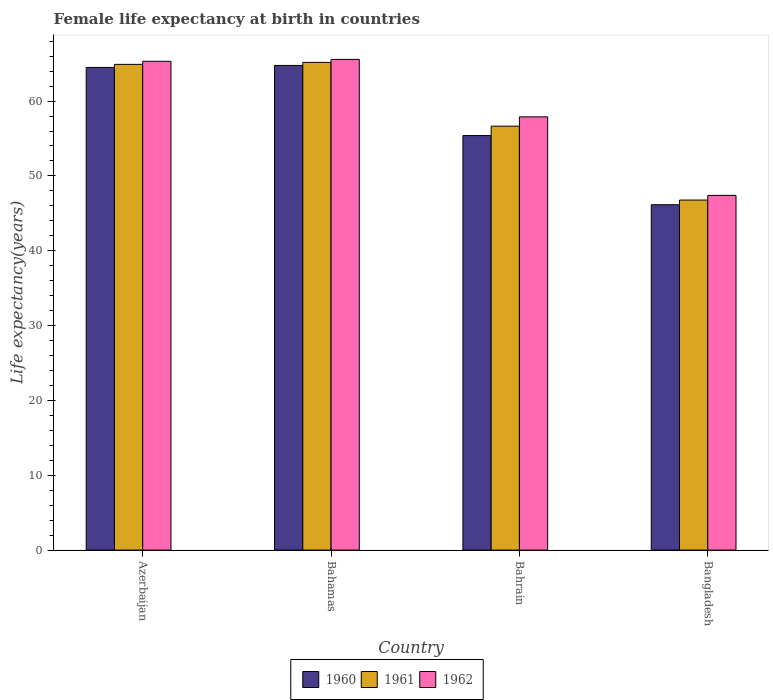How many different coloured bars are there?
Your response must be concise. 3. How many groups of bars are there?
Your answer should be very brief. 4. Are the number of bars per tick equal to the number of legend labels?
Offer a terse response. Yes. How many bars are there on the 3rd tick from the left?
Keep it short and to the point. 3. What is the label of the 1st group of bars from the left?
Offer a terse response. Azerbaijan. What is the female life expectancy at birth in 1960 in Bahrain?
Give a very brief answer. 55.39. Across all countries, what is the maximum female life expectancy at birth in 1962?
Ensure brevity in your answer.  65.57. Across all countries, what is the minimum female life expectancy at birth in 1960?
Give a very brief answer. 46.15. In which country was the female life expectancy at birth in 1961 maximum?
Offer a very short reply. Bahamas. In which country was the female life expectancy at birth in 1962 minimum?
Your response must be concise. Bangladesh. What is the total female life expectancy at birth in 1962 in the graph?
Provide a short and direct response. 236.18. What is the difference between the female life expectancy at birth in 1960 in Azerbaijan and that in Bahrain?
Offer a very short reply. 9.11. What is the difference between the female life expectancy at birth in 1960 in Bahrain and the female life expectancy at birth in 1961 in Azerbaijan?
Your response must be concise. -9.51. What is the average female life expectancy at birth in 1961 per country?
Provide a succinct answer. 58.38. What is the difference between the female life expectancy at birth of/in 1961 and female life expectancy at birth of/in 1962 in Bahrain?
Provide a succinct answer. -1.24. What is the ratio of the female life expectancy at birth in 1962 in Azerbaijan to that in Bahrain?
Keep it short and to the point. 1.13. Is the female life expectancy at birth in 1962 in Azerbaijan less than that in Bahamas?
Ensure brevity in your answer.  Yes. Is the difference between the female life expectancy at birth in 1961 in Azerbaijan and Bangladesh greater than the difference between the female life expectancy at birth in 1962 in Azerbaijan and Bangladesh?
Provide a succinct answer. Yes. What is the difference between the highest and the second highest female life expectancy at birth in 1961?
Ensure brevity in your answer.  -0.27. What is the difference between the highest and the lowest female life expectancy at birth in 1961?
Give a very brief answer. 18.4. In how many countries, is the female life expectancy at birth in 1962 greater than the average female life expectancy at birth in 1962 taken over all countries?
Make the answer very short. 2. What does the 2nd bar from the right in Bangladesh represents?
Your response must be concise. 1961. Are the values on the major ticks of Y-axis written in scientific E-notation?
Offer a terse response. No. Does the graph contain grids?
Make the answer very short. No. Where does the legend appear in the graph?
Your answer should be very brief. Bottom center. How are the legend labels stacked?
Provide a short and direct response. Horizontal. What is the title of the graph?
Keep it short and to the point. Female life expectancy at birth in countries. What is the label or title of the X-axis?
Make the answer very short. Country. What is the label or title of the Y-axis?
Ensure brevity in your answer.  Life expectancy(years). What is the Life expectancy(years) of 1960 in Azerbaijan?
Ensure brevity in your answer.  64.5. What is the Life expectancy(years) in 1961 in Azerbaijan?
Provide a short and direct response. 64.91. What is the Life expectancy(years) of 1962 in Azerbaijan?
Ensure brevity in your answer.  65.32. What is the Life expectancy(years) in 1960 in Bahamas?
Ensure brevity in your answer.  64.76. What is the Life expectancy(years) in 1961 in Bahamas?
Provide a short and direct response. 65.17. What is the Life expectancy(years) of 1962 in Bahamas?
Provide a succinct answer. 65.57. What is the Life expectancy(years) of 1960 in Bahrain?
Your answer should be very brief. 55.39. What is the Life expectancy(years) of 1961 in Bahrain?
Your answer should be compact. 56.65. What is the Life expectancy(years) in 1962 in Bahrain?
Offer a very short reply. 57.89. What is the Life expectancy(years) of 1960 in Bangladesh?
Offer a very short reply. 46.15. What is the Life expectancy(years) in 1961 in Bangladesh?
Your answer should be very brief. 46.78. What is the Life expectancy(years) in 1962 in Bangladesh?
Offer a terse response. 47.4. Across all countries, what is the maximum Life expectancy(years) of 1960?
Your response must be concise. 64.76. Across all countries, what is the maximum Life expectancy(years) of 1961?
Your response must be concise. 65.17. Across all countries, what is the maximum Life expectancy(years) in 1962?
Make the answer very short. 65.57. Across all countries, what is the minimum Life expectancy(years) of 1960?
Your response must be concise. 46.15. Across all countries, what is the minimum Life expectancy(years) of 1961?
Make the answer very short. 46.78. Across all countries, what is the minimum Life expectancy(years) of 1962?
Offer a terse response. 47.4. What is the total Life expectancy(years) of 1960 in the graph?
Provide a short and direct response. 230.81. What is the total Life expectancy(years) of 1961 in the graph?
Provide a short and direct response. 233.5. What is the total Life expectancy(years) of 1962 in the graph?
Give a very brief answer. 236.18. What is the difference between the Life expectancy(years) in 1960 in Azerbaijan and that in Bahamas?
Make the answer very short. -0.26. What is the difference between the Life expectancy(years) in 1961 in Azerbaijan and that in Bahamas?
Make the answer very short. -0.27. What is the difference between the Life expectancy(years) in 1962 in Azerbaijan and that in Bahamas?
Offer a very short reply. -0.25. What is the difference between the Life expectancy(years) of 1960 in Azerbaijan and that in Bahrain?
Your answer should be very brief. 9.11. What is the difference between the Life expectancy(years) in 1961 in Azerbaijan and that in Bahrain?
Offer a terse response. 8.26. What is the difference between the Life expectancy(years) in 1962 in Azerbaijan and that in Bahrain?
Your response must be concise. 7.42. What is the difference between the Life expectancy(years) of 1960 in Azerbaijan and that in Bangladesh?
Your answer should be very brief. 18.35. What is the difference between the Life expectancy(years) in 1961 in Azerbaijan and that in Bangladesh?
Provide a succinct answer. 18.13. What is the difference between the Life expectancy(years) of 1962 in Azerbaijan and that in Bangladesh?
Give a very brief answer. 17.92. What is the difference between the Life expectancy(years) of 1960 in Bahamas and that in Bahrain?
Your answer should be very brief. 9.37. What is the difference between the Life expectancy(years) in 1961 in Bahamas and that in Bahrain?
Ensure brevity in your answer.  8.52. What is the difference between the Life expectancy(years) of 1962 in Bahamas and that in Bahrain?
Ensure brevity in your answer.  7.68. What is the difference between the Life expectancy(years) in 1960 in Bahamas and that in Bangladesh?
Provide a succinct answer. 18.61. What is the difference between the Life expectancy(years) in 1961 in Bahamas and that in Bangladesh?
Provide a short and direct response. 18.4. What is the difference between the Life expectancy(years) of 1962 in Bahamas and that in Bangladesh?
Offer a terse response. 18.17. What is the difference between the Life expectancy(years) in 1960 in Bahrain and that in Bangladesh?
Ensure brevity in your answer.  9.24. What is the difference between the Life expectancy(years) in 1961 in Bahrain and that in Bangladesh?
Offer a very short reply. 9.87. What is the difference between the Life expectancy(years) in 1962 in Bahrain and that in Bangladesh?
Keep it short and to the point. 10.49. What is the difference between the Life expectancy(years) in 1960 in Azerbaijan and the Life expectancy(years) in 1961 in Bahamas?
Give a very brief answer. -0.67. What is the difference between the Life expectancy(years) in 1960 in Azerbaijan and the Life expectancy(years) in 1962 in Bahamas?
Your answer should be very brief. -1.07. What is the difference between the Life expectancy(years) of 1961 in Azerbaijan and the Life expectancy(years) of 1962 in Bahamas?
Provide a succinct answer. -0.66. What is the difference between the Life expectancy(years) of 1960 in Azerbaijan and the Life expectancy(years) of 1961 in Bahrain?
Ensure brevity in your answer.  7.85. What is the difference between the Life expectancy(years) in 1960 in Azerbaijan and the Life expectancy(years) in 1962 in Bahrain?
Provide a short and direct response. 6.61. What is the difference between the Life expectancy(years) of 1961 in Azerbaijan and the Life expectancy(years) of 1962 in Bahrain?
Make the answer very short. 7.01. What is the difference between the Life expectancy(years) of 1960 in Azerbaijan and the Life expectancy(years) of 1961 in Bangladesh?
Your answer should be compact. 17.73. What is the difference between the Life expectancy(years) in 1960 in Azerbaijan and the Life expectancy(years) in 1962 in Bangladesh?
Offer a very short reply. 17.1. What is the difference between the Life expectancy(years) in 1961 in Azerbaijan and the Life expectancy(years) in 1962 in Bangladesh?
Ensure brevity in your answer.  17.51. What is the difference between the Life expectancy(years) of 1960 in Bahamas and the Life expectancy(years) of 1961 in Bahrain?
Your answer should be compact. 8.11. What is the difference between the Life expectancy(years) in 1960 in Bahamas and the Life expectancy(years) in 1962 in Bahrain?
Your response must be concise. 6.87. What is the difference between the Life expectancy(years) in 1961 in Bahamas and the Life expectancy(years) in 1962 in Bahrain?
Your answer should be very brief. 7.28. What is the difference between the Life expectancy(years) in 1960 in Bahamas and the Life expectancy(years) in 1961 in Bangladesh?
Make the answer very short. 17.99. What is the difference between the Life expectancy(years) in 1960 in Bahamas and the Life expectancy(years) in 1962 in Bangladesh?
Your response must be concise. 17.36. What is the difference between the Life expectancy(years) of 1961 in Bahamas and the Life expectancy(years) of 1962 in Bangladesh?
Provide a short and direct response. 17.77. What is the difference between the Life expectancy(years) in 1960 in Bahrain and the Life expectancy(years) in 1961 in Bangladesh?
Provide a short and direct response. 8.62. What is the difference between the Life expectancy(years) in 1960 in Bahrain and the Life expectancy(years) in 1962 in Bangladesh?
Provide a short and direct response. 7.99. What is the difference between the Life expectancy(years) of 1961 in Bahrain and the Life expectancy(years) of 1962 in Bangladesh?
Offer a very short reply. 9.25. What is the average Life expectancy(years) of 1960 per country?
Offer a terse response. 57.7. What is the average Life expectancy(years) of 1961 per country?
Make the answer very short. 58.38. What is the average Life expectancy(years) of 1962 per country?
Your answer should be very brief. 59.05. What is the difference between the Life expectancy(years) of 1960 and Life expectancy(years) of 1961 in Azerbaijan?
Offer a very short reply. -0.41. What is the difference between the Life expectancy(years) in 1960 and Life expectancy(years) in 1962 in Azerbaijan?
Make the answer very short. -0.81. What is the difference between the Life expectancy(years) in 1961 and Life expectancy(years) in 1962 in Azerbaijan?
Provide a short and direct response. -0.41. What is the difference between the Life expectancy(years) of 1960 and Life expectancy(years) of 1961 in Bahamas?
Offer a very short reply. -0.41. What is the difference between the Life expectancy(years) of 1960 and Life expectancy(years) of 1962 in Bahamas?
Make the answer very short. -0.81. What is the difference between the Life expectancy(years) of 1961 and Life expectancy(years) of 1962 in Bahamas?
Keep it short and to the point. -0.4. What is the difference between the Life expectancy(years) in 1960 and Life expectancy(years) in 1961 in Bahrain?
Ensure brevity in your answer.  -1.26. What is the difference between the Life expectancy(years) of 1960 and Life expectancy(years) of 1962 in Bahrain?
Provide a succinct answer. -2.5. What is the difference between the Life expectancy(years) in 1961 and Life expectancy(years) in 1962 in Bahrain?
Make the answer very short. -1.24. What is the difference between the Life expectancy(years) in 1960 and Life expectancy(years) in 1961 in Bangladesh?
Offer a very short reply. -0.62. What is the difference between the Life expectancy(years) of 1960 and Life expectancy(years) of 1962 in Bangladesh?
Provide a short and direct response. -1.25. What is the difference between the Life expectancy(years) of 1961 and Life expectancy(years) of 1962 in Bangladesh?
Your answer should be compact. -0.62. What is the ratio of the Life expectancy(years) in 1962 in Azerbaijan to that in Bahamas?
Provide a short and direct response. 1. What is the ratio of the Life expectancy(years) of 1960 in Azerbaijan to that in Bahrain?
Ensure brevity in your answer.  1.16. What is the ratio of the Life expectancy(years) of 1961 in Azerbaijan to that in Bahrain?
Provide a short and direct response. 1.15. What is the ratio of the Life expectancy(years) of 1962 in Azerbaijan to that in Bahrain?
Offer a terse response. 1.13. What is the ratio of the Life expectancy(years) of 1960 in Azerbaijan to that in Bangladesh?
Ensure brevity in your answer.  1.4. What is the ratio of the Life expectancy(years) of 1961 in Azerbaijan to that in Bangladesh?
Give a very brief answer. 1.39. What is the ratio of the Life expectancy(years) in 1962 in Azerbaijan to that in Bangladesh?
Your answer should be very brief. 1.38. What is the ratio of the Life expectancy(years) in 1960 in Bahamas to that in Bahrain?
Keep it short and to the point. 1.17. What is the ratio of the Life expectancy(years) of 1961 in Bahamas to that in Bahrain?
Ensure brevity in your answer.  1.15. What is the ratio of the Life expectancy(years) in 1962 in Bahamas to that in Bahrain?
Make the answer very short. 1.13. What is the ratio of the Life expectancy(years) of 1960 in Bahamas to that in Bangladesh?
Offer a terse response. 1.4. What is the ratio of the Life expectancy(years) in 1961 in Bahamas to that in Bangladesh?
Make the answer very short. 1.39. What is the ratio of the Life expectancy(years) of 1962 in Bahamas to that in Bangladesh?
Your answer should be very brief. 1.38. What is the ratio of the Life expectancy(years) in 1960 in Bahrain to that in Bangladesh?
Offer a very short reply. 1.2. What is the ratio of the Life expectancy(years) of 1961 in Bahrain to that in Bangladesh?
Provide a succinct answer. 1.21. What is the ratio of the Life expectancy(years) in 1962 in Bahrain to that in Bangladesh?
Your answer should be compact. 1.22. What is the difference between the highest and the second highest Life expectancy(years) in 1960?
Offer a very short reply. 0.26. What is the difference between the highest and the second highest Life expectancy(years) in 1961?
Offer a terse response. 0.27. What is the difference between the highest and the second highest Life expectancy(years) in 1962?
Provide a short and direct response. 0.25. What is the difference between the highest and the lowest Life expectancy(years) of 1960?
Ensure brevity in your answer.  18.61. What is the difference between the highest and the lowest Life expectancy(years) in 1961?
Ensure brevity in your answer.  18.4. What is the difference between the highest and the lowest Life expectancy(years) of 1962?
Your response must be concise. 18.17. 